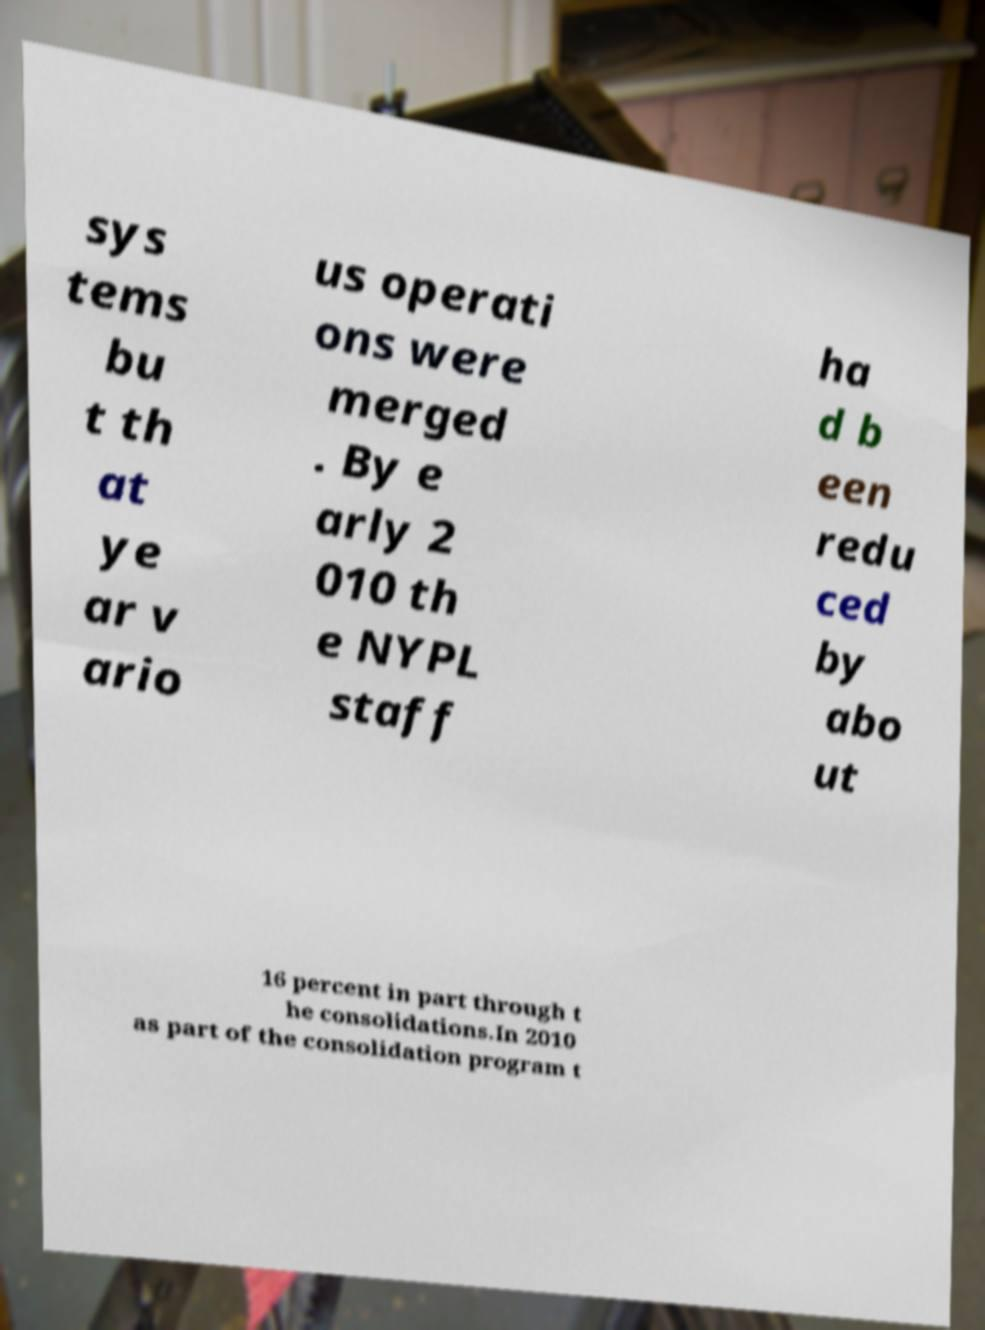Please identify and transcribe the text found in this image. sys tems bu t th at ye ar v ario us operati ons were merged . By e arly 2 010 th e NYPL staff ha d b een redu ced by abo ut 16 percent in part through t he consolidations.In 2010 as part of the consolidation program t 